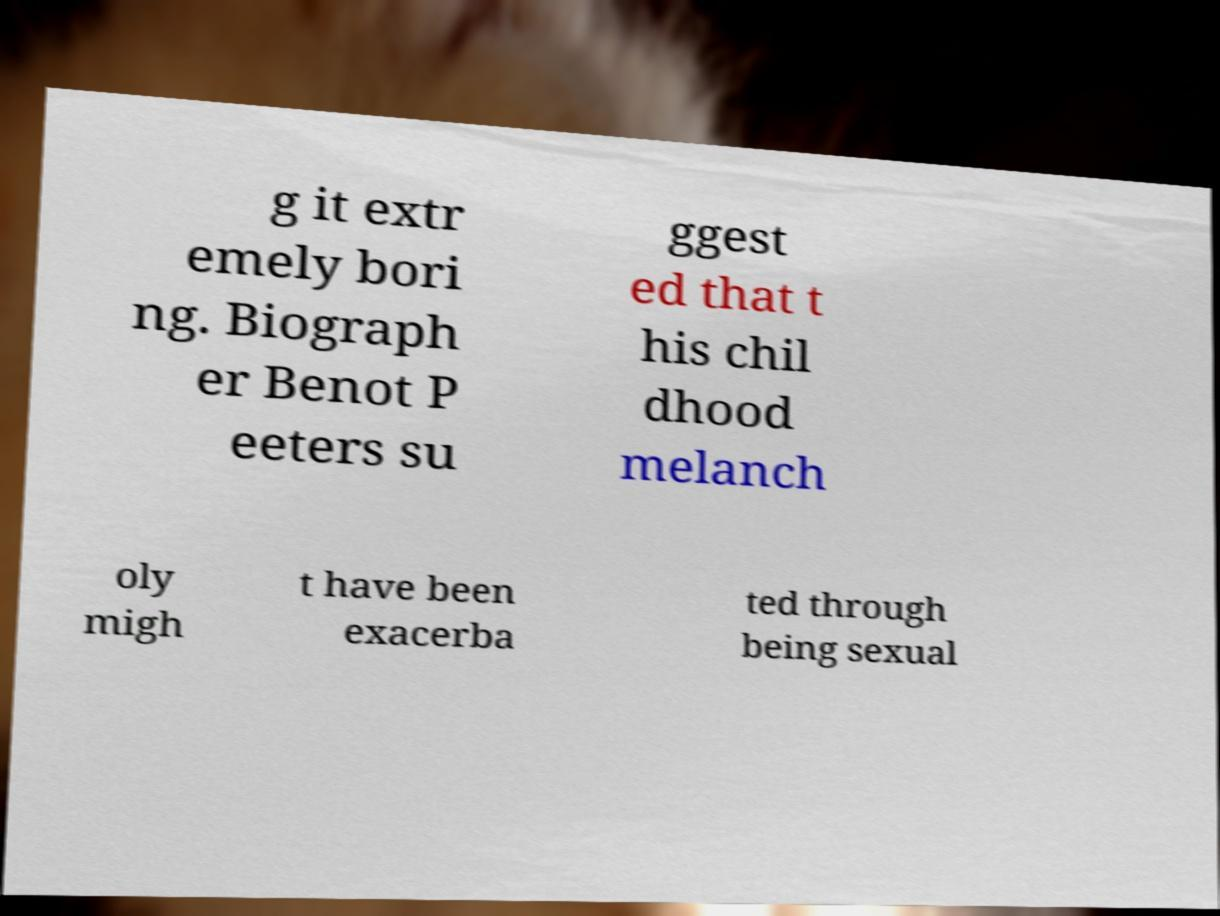Can you accurately transcribe the text from the provided image for me? g it extr emely bori ng. Biograph er Benot P eeters su ggest ed that t his chil dhood melanch oly migh t have been exacerba ted through being sexual 